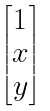Convert formula to latex. <formula><loc_0><loc_0><loc_500><loc_500>\begin{bmatrix} 1 \\ x \\ y \end{bmatrix}</formula> 